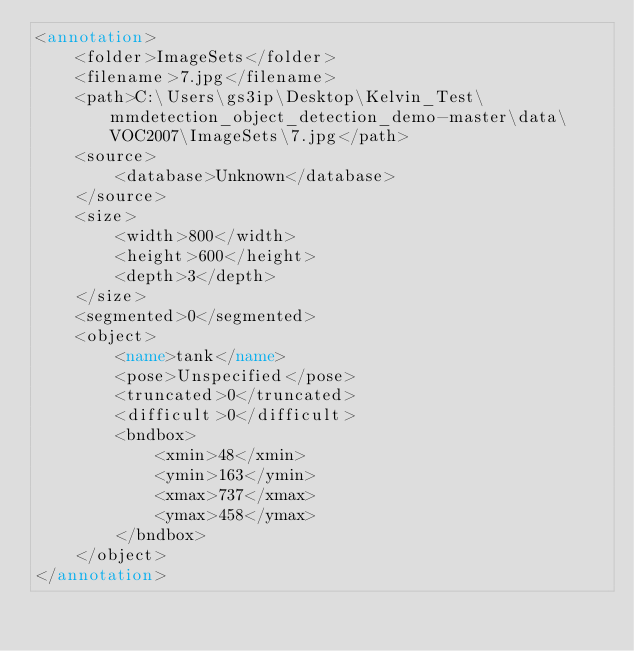<code> <loc_0><loc_0><loc_500><loc_500><_XML_><annotation>
	<folder>ImageSets</folder>
	<filename>7.jpg</filename>
	<path>C:\Users\gs3ip\Desktop\Kelvin_Test\mmdetection_object_detection_demo-master\data\VOC2007\ImageSets\7.jpg</path>
	<source>
		<database>Unknown</database>
	</source>
	<size>
		<width>800</width>
		<height>600</height>
		<depth>3</depth>
	</size>
	<segmented>0</segmented>
	<object>
		<name>tank</name>
		<pose>Unspecified</pose>
		<truncated>0</truncated>
		<difficult>0</difficult>
		<bndbox>
			<xmin>48</xmin>
			<ymin>163</ymin>
			<xmax>737</xmax>
			<ymax>458</ymax>
		</bndbox>
	</object>
</annotation>
</code> 